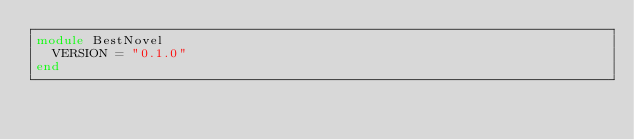Convert code to text. <code><loc_0><loc_0><loc_500><loc_500><_Ruby_>module BestNovel
  VERSION = "0.1.0"
end
</code> 